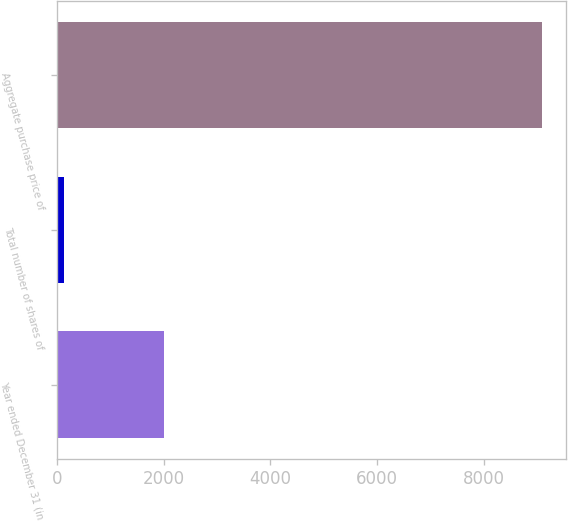Convert chart to OTSL. <chart><loc_0><loc_0><loc_500><loc_500><bar_chart><fcel>Year ended December 31 (in<fcel>Total number of shares of<fcel>Aggregate purchase price of<nl><fcel>2016<fcel>140.4<fcel>9082<nl></chart> 